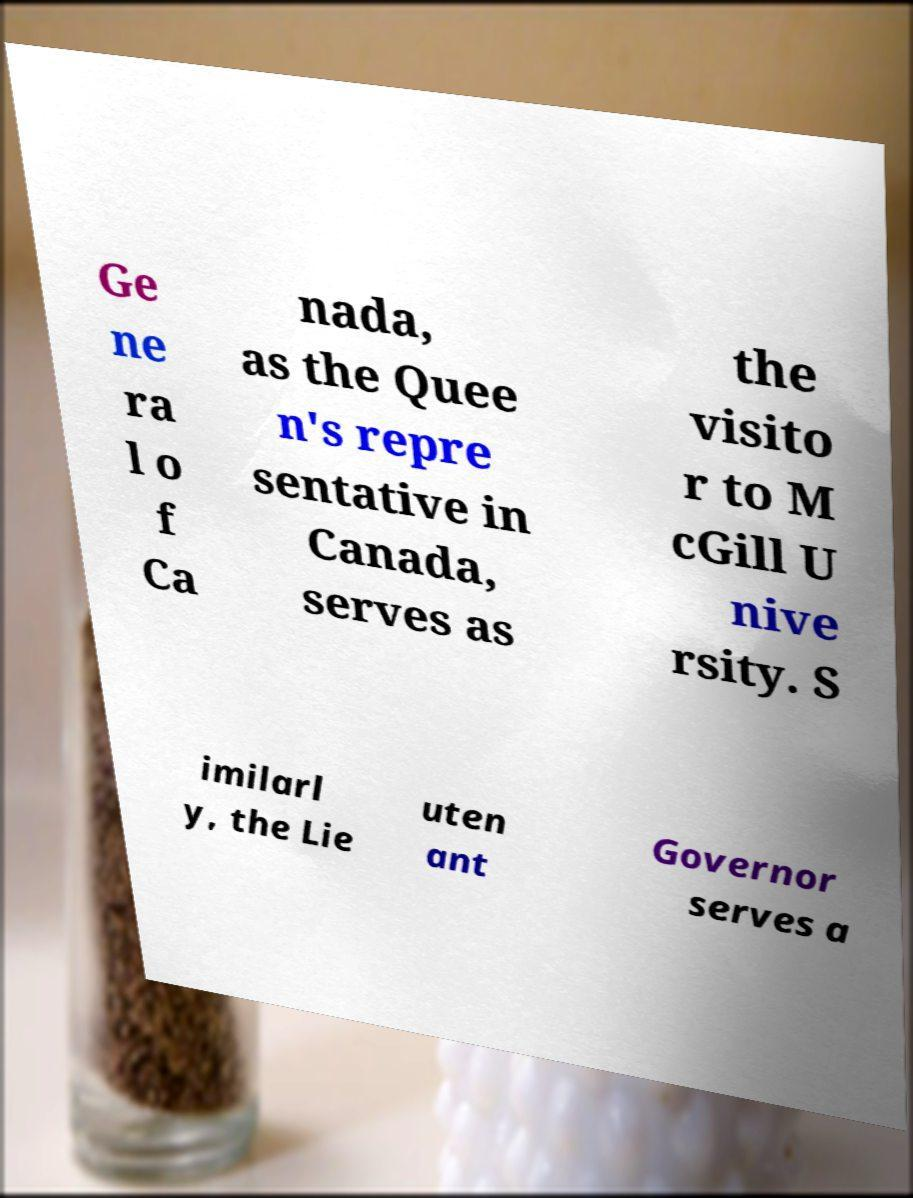What messages or text are displayed in this image? I need them in a readable, typed format. Ge ne ra l o f Ca nada, as the Quee n's repre sentative in Canada, serves as the visito r to M cGill U nive rsity. S imilarl y, the Lie uten ant Governor serves a 